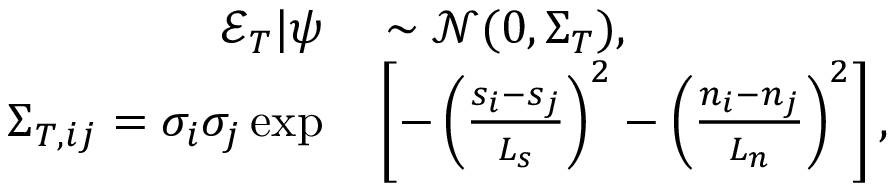<formula> <loc_0><loc_0><loc_500><loc_500>\begin{array} { r l } { \mathcal { E } _ { T } | \psi } & \sim \mathcal { N } ( 0 , \Sigma _ { T } ) , } \\ { { \Sigma } _ { T , i j } = \sigma _ { i } \sigma _ { j } \exp } & \left [ - \left ( \frac { s _ { i } - s _ { j } } { L _ { s } } \right ) ^ { 2 } - \left ( \frac { n _ { i } - n _ { j } } { L _ { n } } \right ) ^ { 2 } \right ] , } \end{array}</formula> 